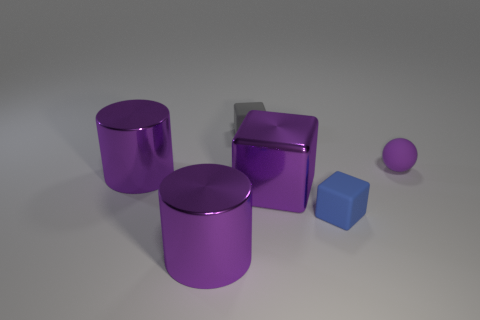Add 1 purple balls. How many objects exist? 7 Subtract all spheres. How many objects are left? 5 Subtract 0 yellow cubes. How many objects are left? 6 Subtract all small gray objects. Subtract all purple metal cubes. How many objects are left? 4 Add 1 tiny rubber blocks. How many tiny rubber blocks are left? 3 Add 1 blue things. How many blue things exist? 2 